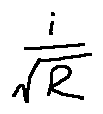<formula> <loc_0><loc_0><loc_500><loc_500>\frac { i } { \sqrt { R } }</formula> 